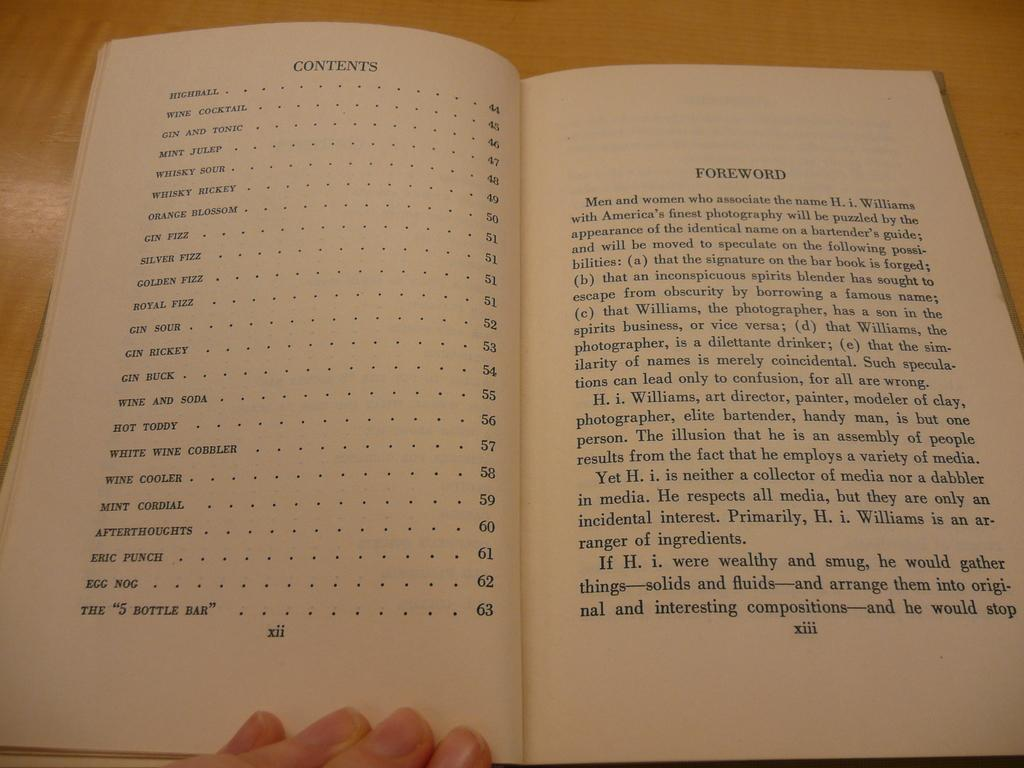<image>
Present a compact description of the photo's key features. Someone holds the book open to the table of contents, which includes egg nog and mint cordials. 